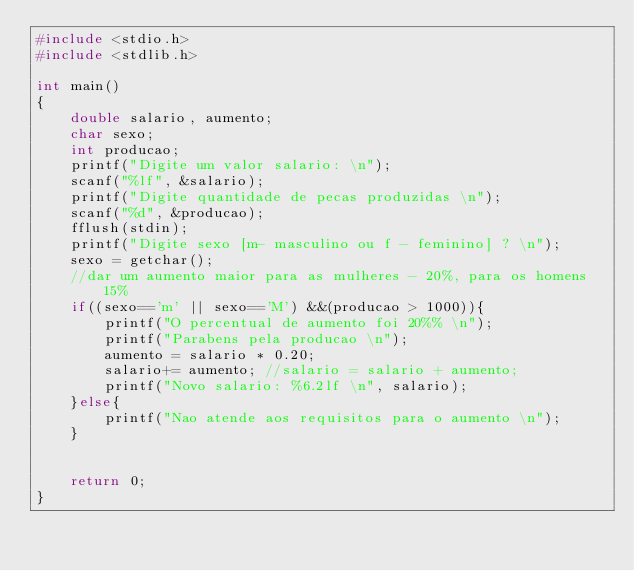<code> <loc_0><loc_0><loc_500><loc_500><_C_>#include <stdio.h>
#include <stdlib.h>

int main()
{
    double salario, aumento;
    char sexo;
    int producao;
    printf("Digite um valor salario: \n");
    scanf("%lf", &salario);
    printf("Digite quantidade de pecas produzidas \n");
    scanf("%d", &producao);
    fflush(stdin);
    printf("Digite sexo [m- masculino ou f - feminino] ? \n");
    sexo = getchar();
    //dar um aumento maior para as mulheres - 20%, para os homens 15%
    if((sexo=='m' || sexo=='M') &&(producao > 1000)){
        printf("O percentual de aumento foi 20%% \n");
        printf("Parabens pela producao \n");
        aumento = salario * 0.20;
        salario+= aumento; //salario = salario + aumento;
        printf("Novo salario: %6.2lf \n", salario);
    }else{
        printf("Nao atende aos requisitos para o aumento \n");
    }


    return 0;
}
</code> 